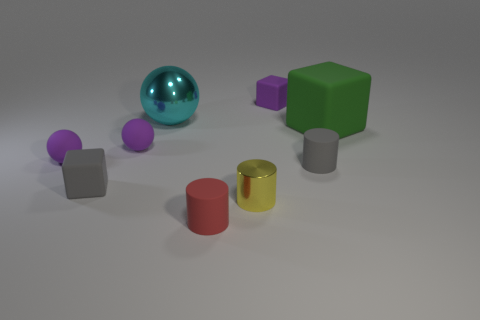What number of objects are gray things on the left side of the gray rubber cylinder or tiny matte things in front of the big green block?
Make the answer very short. 5. There is a yellow shiny thing that is the same size as the red matte object; what is its shape?
Offer a terse response. Cylinder. The metal object that is in front of the cube right of the purple matte cube behind the large cyan sphere is what shape?
Provide a short and direct response. Cylinder. Are there an equal number of small red matte objects that are in front of the large cyan metal sphere and small green metallic cylinders?
Offer a very short reply. No. Is the cyan metallic sphere the same size as the green matte cube?
Give a very brief answer. Yes. What number of matte objects are either yellow things or big things?
Offer a very short reply. 1. What is the material of the gray cylinder that is the same size as the red object?
Your answer should be very brief. Rubber. What number of other things are there of the same material as the green thing
Provide a succinct answer. 6. Are there fewer green matte objects that are to the left of the cyan metallic object than big green metal balls?
Your answer should be very brief. No. Does the red object have the same shape as the small yellow object?
Make the answer very short. Yes. 